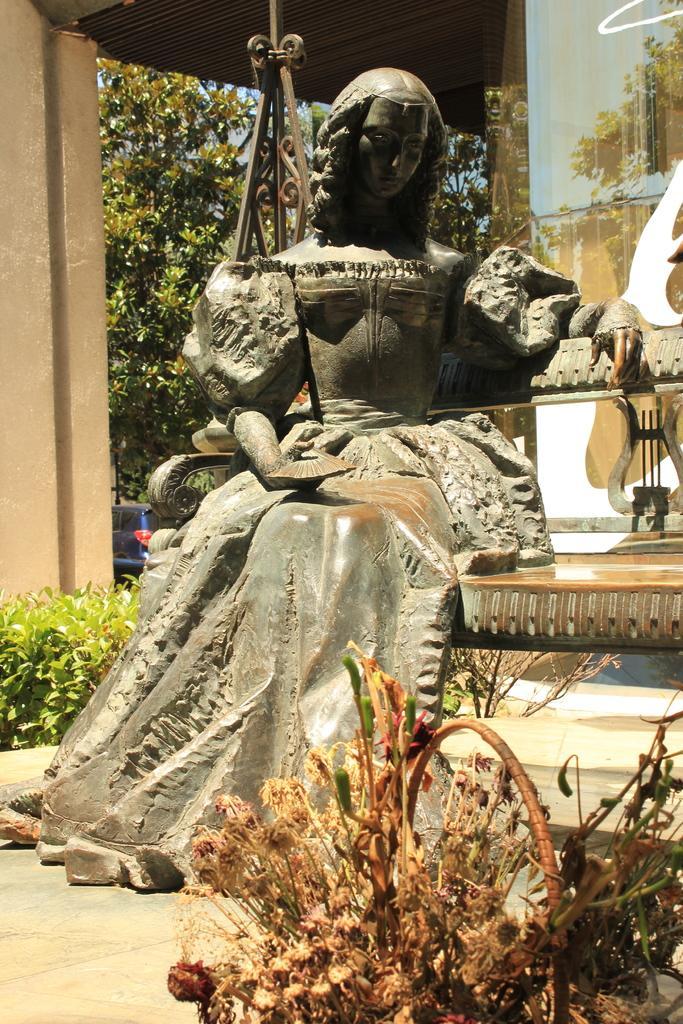How would you summarize this image in a sentence or two? In this picture we can see a statue of a woman, plants, basket, bench, pillar, wall, rods, roof and some objects and in the background we can see trees. 